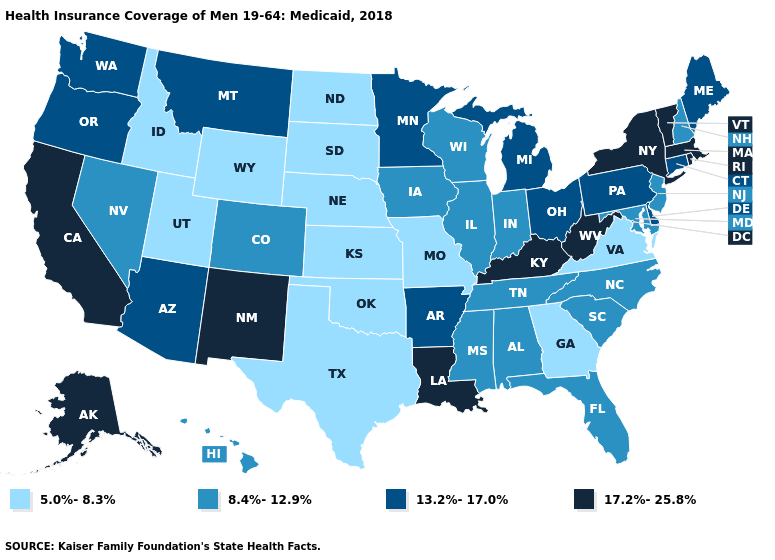What is the value of Connecticut?
Keep it brief. 13.2%-17.0%. Does the map have missing data?
Be succinct. No. Does Michigan have the highest value in the MidWest?
Short answer required. Yes. Does Maryland have the same value as North Dakota?
Concise answer only. No. What is the highest value in the USA?
Short answer required. 17.2%-25.8%. What is the highest value in the USA?
Be succinct. 17.2%-25.8%. Among the states that border Massachusetts , which have the highest value?
Give a very brief answer. New York, Rhode Island, Vermont. Among the states that border Arizona , does Nevada have the lowest value?
Keep it brief. No. Among the states that border North Dakota , which have the lowest value?
Answer briefly. South Dakota. Does New Mexico have a lower value than Nevada?
Short answer required. No. What is the value of Montana?
Write a very short answer. 13.2%-17.0%. What is the lowest value in states that border North Carolina?
Short answer required. 5.0%-8.3%. Among the states that border California , does Nevada have the lowest value?
Give a very brief answer. Yes. Name the states that have a value in the range 5.0%-8.3%?
Be succinct. Georgia, Idaho, Kansas, Missouri, Nebraska, North Dakota, Oklahoma, South Dakota, Texas, Utah, Virginia, Wyoming. Does North Dakota have the same value as Georgia?
Short answer required. Yes. 